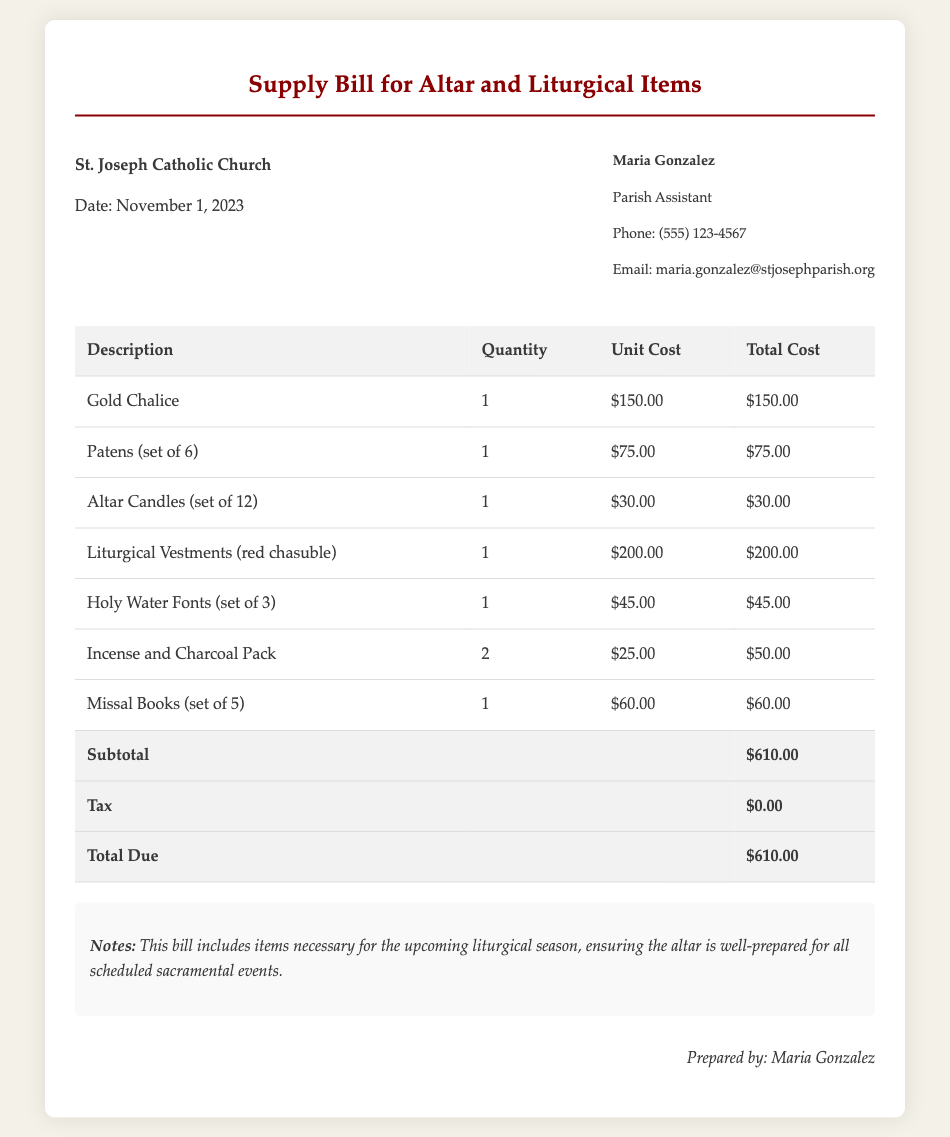What is the date of the bill? The date is provided in the header of the document, indicating when the bill was issued.
Answer: November 1, 2023 What is the name of the parish assistant? The name is stated in the contact information section of the document.
Answer: Maria Gonzalez How many sets of altar candles are included in the bill? The quantity of altar candles is specified for the corresponding item in the table.
Answer: 1 What is the total cost of the supply bill? The total cost is presented at the end of the table after adding up all item costs and tax.
Answer: $610.00 What type of vestments are purchased? The description specifies the type of vestments listed in the bill.
Answer: red chasuble How much does a set of Patens cost? The unit cost is provided next to the description of the Patens in the table.
Answer: $75.00 What is the subtotal amount before tax? The subtotal is indicated in the total row of the bill prior to the tax calculation.
Answer: $610.00 How many Holy Water Fonts are included in the purchase? The quantity of Holy Water Fonts is stated in the corresponding item line.
Answer: 1 Is there any tax applied to the bill? The tax amount is detailed in the total section of the document.
Answer: $0.00 